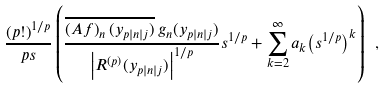<formula> <loc_0><loc_0><loc_500><loc_500>\frac { { ( p ! ) } ^ { 1 / p } } { p s } \left ( \frac { \overline { \left ( A f \right ) _ { n } ( y _ { p | n | j } ) } \, g _ { n } ( y _ { p | n | j } ) } { { \left | R ^ { ( p ) } ( y _ { p | n | j } ) \right | } ^ { 1 / p } } s ^ { 1 / p } + \sum _ { k = 2 } ^ { \infty } a _ { k } { \left ( s ^ { 1 / p } \right ) } ^ { k } \right ) \ ,</formula> 